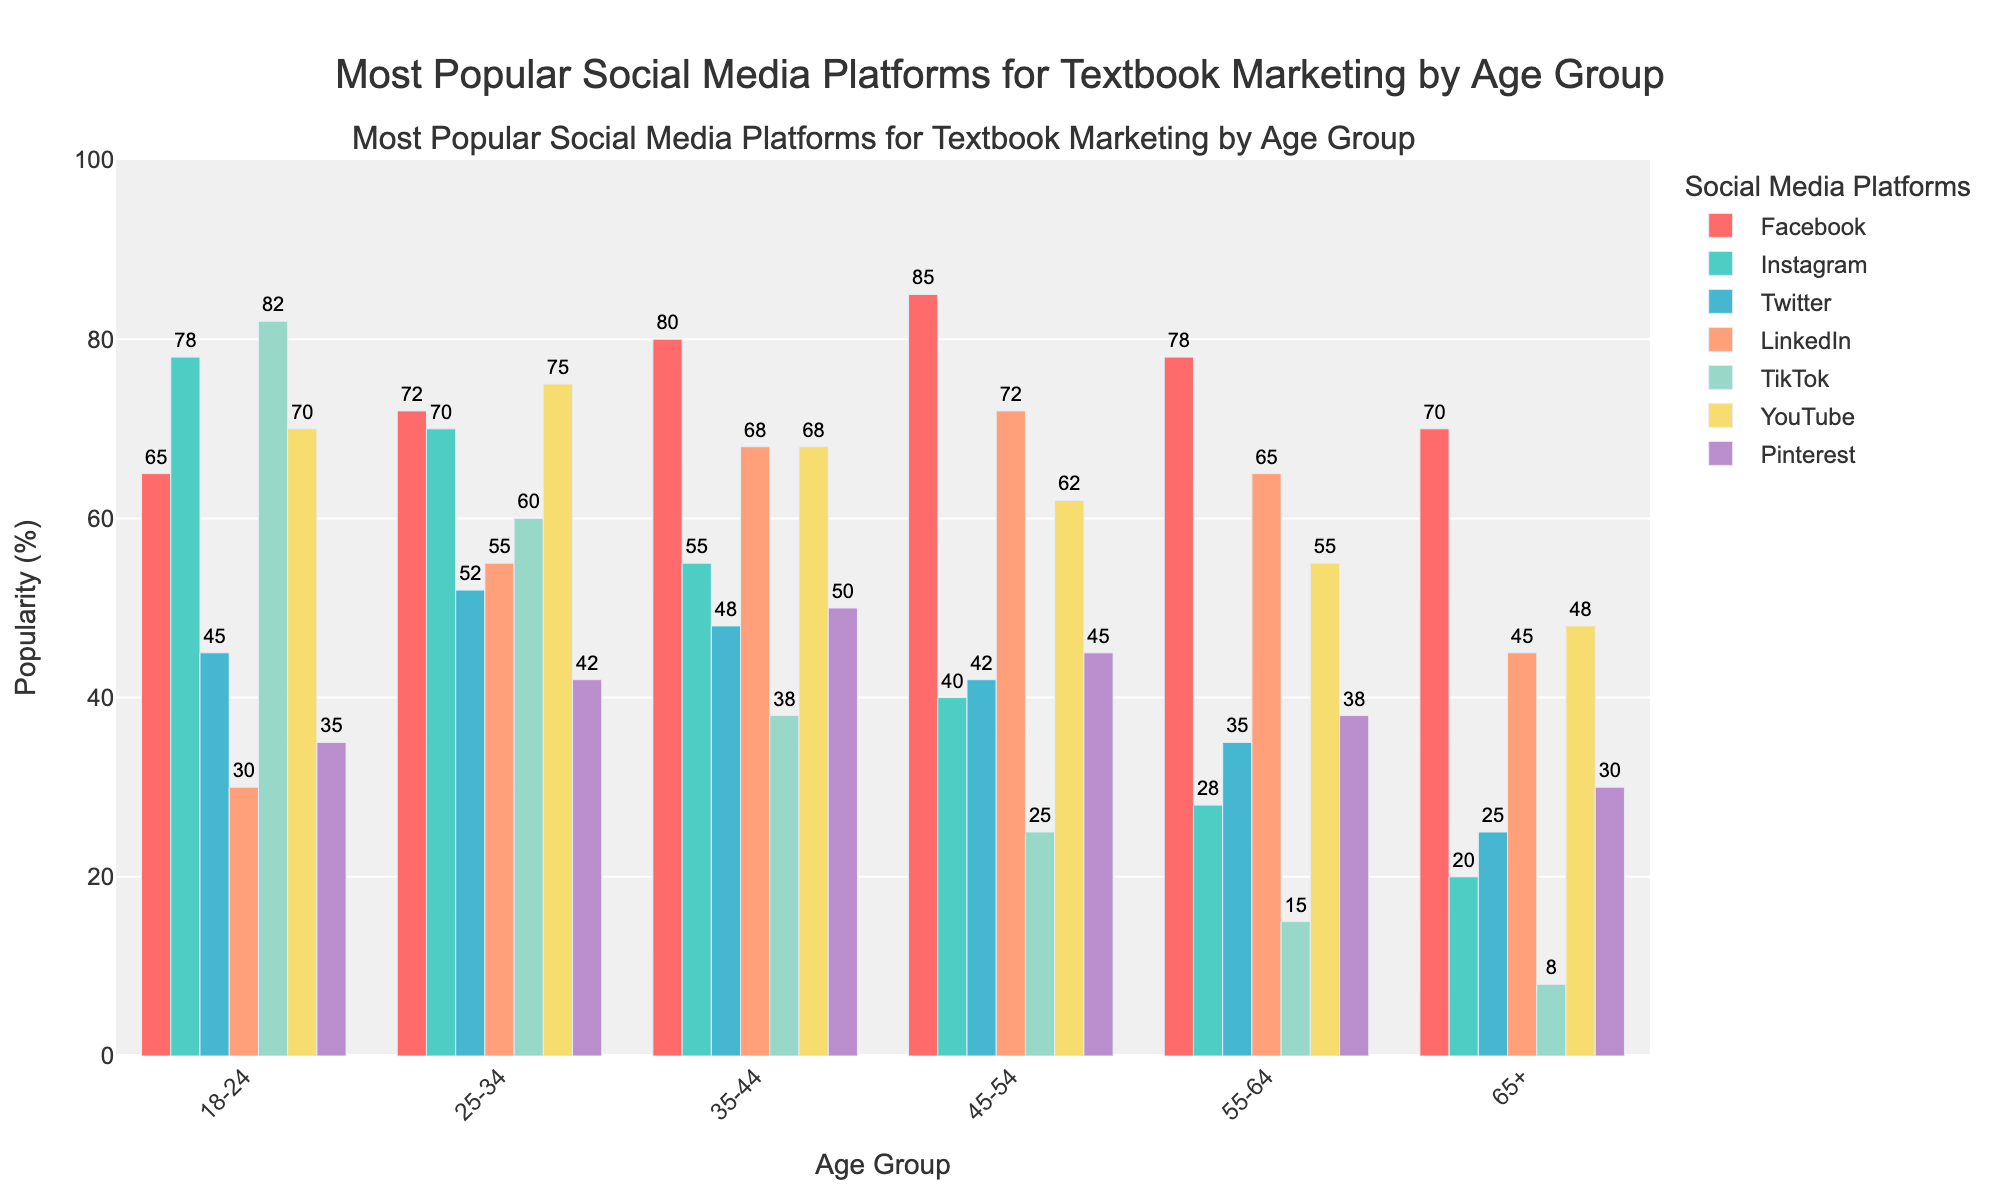What is the most popular social media platform for the 18-24 age group? The figure shows the popularity percentages for each platform. Look for the highest bar within this age group. TikTok's bar is the tallest at 82%.
Answer: TikTok Which age group uses Facebook the most? Check the heights of the Facebook bars across all age groups. The 45-54 age group has the tallest bar at 85%.
Answer: 45-54 Is LinkedIn more popular for the 25-34 age group or the 55-64 age group? Compare the heights of the LinkedIn bars for both age groups. The 25-34 group has a taller bar at 55% compared to 65% for the 55-64 group.
Answer: 55-64 Which social media platform shows a noticeable decrease in popularity as the age group increases, starting from 18-24 to 65+? Look across all age groups for a platform where the bars decrease from left to right. TikTok's bars consistently decrease from 82% to 8%.
Answer: TikTok By how much is the popularity of Instagram for the 18-24 age group greater than for the 45-54 age group? Subtract the percentage for the 45-54 group from that of the 18-24 group. 78% (18-24) - 40% (45-54) = 38%.
Answer: 38% In which age group does YouTube maintain a consistent popularity level similar to Facebook? Look for age groups where YouTube and Facebook bars are close in value. The 35-44 age group shows YouTube at 68% and Facebook at 80%.
Answer: 35-44 What is the average popularity of Twitter across all age groups? Add up the Twitter percentages for all age groups and then divide by the number of age groups. (45 + 52 + 48 + 42 + 35 + 25) / 6 ≈ 41.17%.
Answer: 41.17% Compare the popularity of Facebook and Pinterest for the 35-44 age group. Which one is higher, and by how much? Check the heights of the Facebook and Pinterest bars for the 35-44 age group. Facebook is at 80%, and Pinterest is at 50%. 80% - 50% = 30%.
Answer: Facebook by 30% What is the total combined popularity percentage of YouTube for the 18-24 and 25-34 age groups? Add the popularity percentages of YouTube for the 18-24 and 25-34 age groups. 70% (18-24) + 75% (25-34) = 145%.
Answer: 145% Is Pinterest more popular among the 18-24 age group compared to the 55-64 age group? Compare the heights of the Pinterest bars for both age groups. The 18-24 age group has a bar at 35%, and the 55-64 age group has a bar at 38%.
Answer: No 